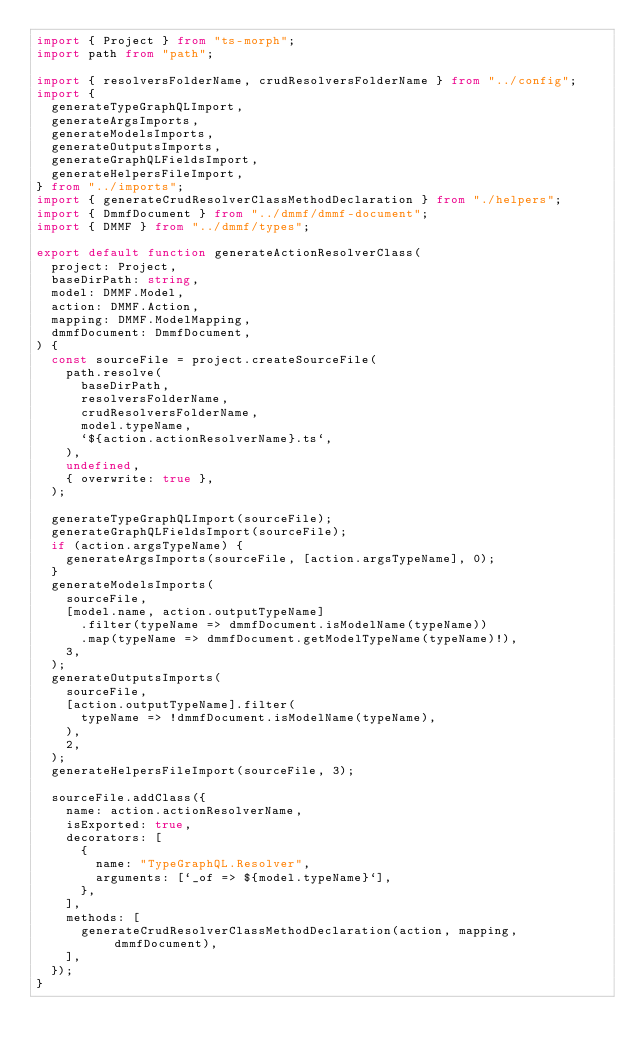Convert code to text. <code><loc_0><loc_0><loc_500><loc_500><_TypeScript_>import { Project } from "ts-morph";
import path from "path";

import { resolversFolderName, crudResolversFolderName } from "../config";
import {
  generateTypeGraphQLImport,
  generateArgsImports,
  generateModelsImports,
  generateOutputsImports,
  generateGraphQLFieldsImport,
  generateHelpersFileImport,
} from "../imports";
import { generateCrudResolverClassMethodDeclaration } from "./helpers";
import { DmmfDocument } from "../dmmf/dmmf-document";
import { DMMF } from "../dmmf/types";

export default function generateActionResolverClass(
  project: Project,
  baseDirPath: string,
  model: DMMF.Model,
  action: DMMF.Action,
  mapping: DMMF.ModelMapping,
  dmmfDocument: DmmfDocument,
) {
  const sourceFile = project.createSourceFile(
    path.resolve(
      baseDirPath,
      resolversFolderName,
      crudResolversFolderName,
      model.typeName,
      `${action.actionResolverName}.ts`,
    ),
    undefined,
    { overwrite: true },
  );

  generateTypeGraphQLImport(sourceFile);
  generateGraphQLFieldsImport(sourceFile);
  if (action.argsTypeName) {
    generateArgsImports(sourceFile, [action.argsTypeName], 0);
  }
  generateModelsImports(
    sourceFile,
    [model.name, action.outputTypeName]
      .filter(typeName => dmmfDocument.isModelName(typeName))
      .map(typeName => dmmfDocument.getModelTypeName(typeName)!),
    3,
  );
  generateOutputsImports(
    sourceFile,
    [action.outputTypeName].filter(
      typeName => !dmmfDocument.isModelName(typeName),
    ),
    2,
  );
  generateHelpersFileImport(sourceFile, 3);

  sourceFile.addClass({
    name: action.actionResolverName,
    isExported: true,
    decorators: [
      {
        name: "TypeGraphQL.Resolver",
        arguments: [`_of => ${model.typeName}`],
      },
    ],
    methods: [
      generateCrudResolverClassMethodDeclaration(action, mapping, dmmfDocument),
    ],
  });
}
</code> 